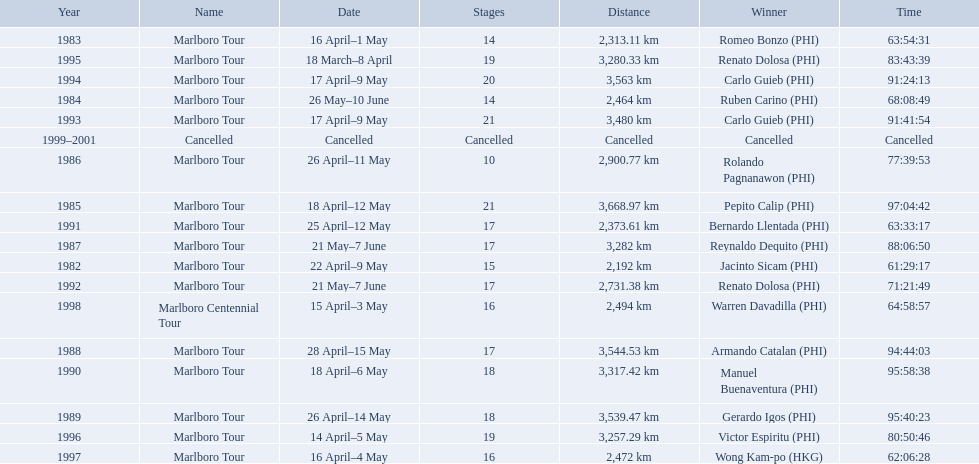Which year did warren davdilla (w.d.) appear? 1998. What tour did w.d. complete? Marlboro Centennial Tour. What is the time recorded in the same row as w.d.? 64:58:57. 